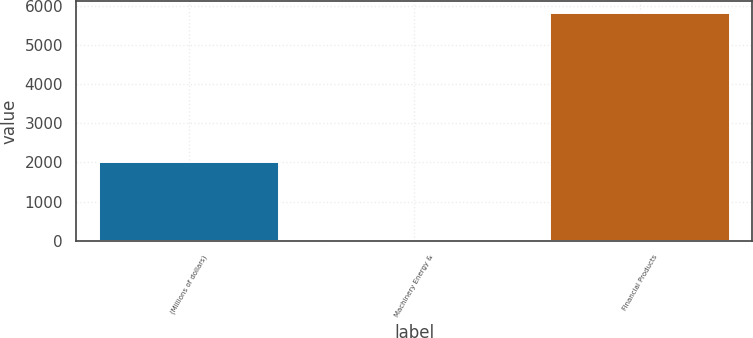Convert chart. <chart><loc_0><loc_0><loc_500><loc_500><bar_chart><fcel>(Millions of dollars)<fcel>Machinery Energy &<fcel>Financial Products<nl><fcel>2019<fcel>10<fcel>5820<nl></chart> 